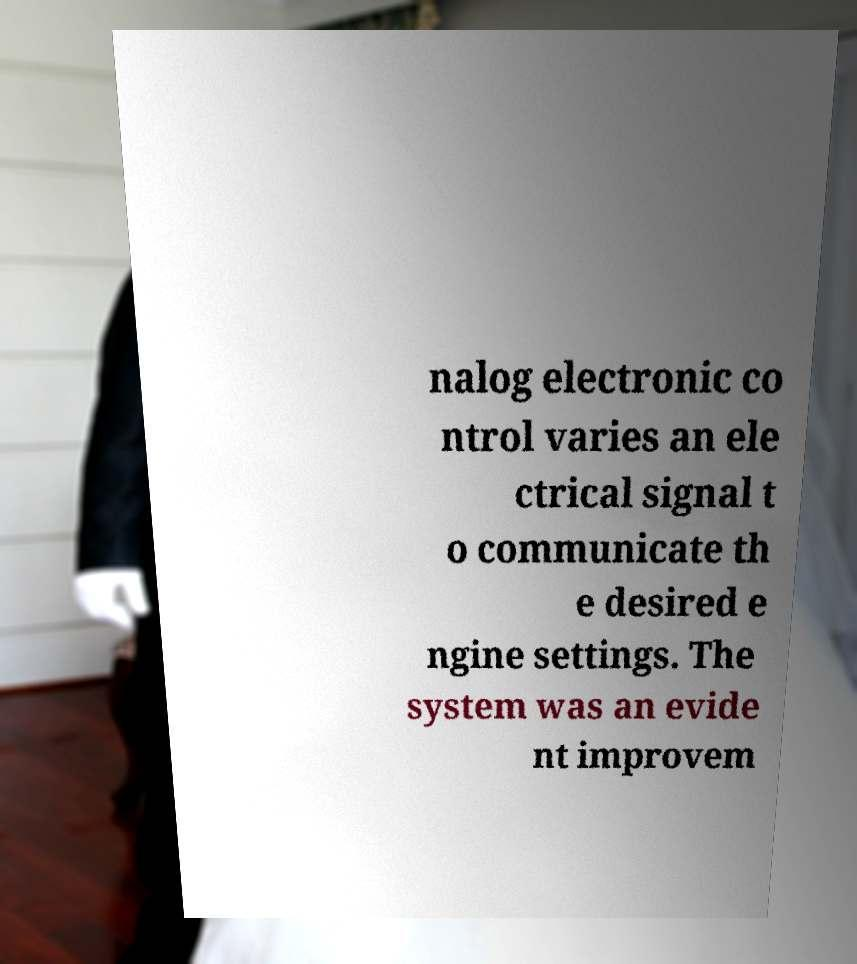Can you read and provide the text displayed in the image?This photo seems to have some interesting text. Can you extract and type it out for me? nalog electronic co ntrol varies an ele ctrical signal t o communicate th e desired e ngine settings. The system was an evide nt improvem 